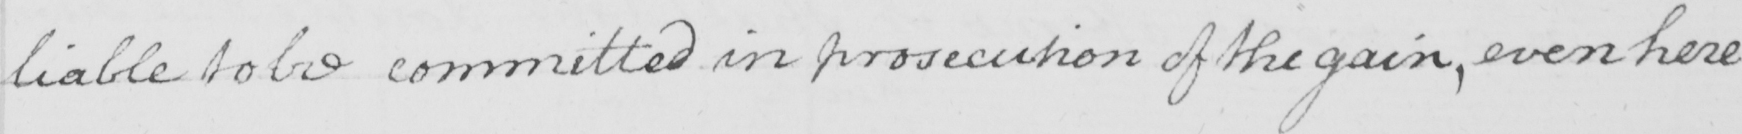Please transcribe the handwritten text in this image. liable to be committed in prosecution of the gain , even here 